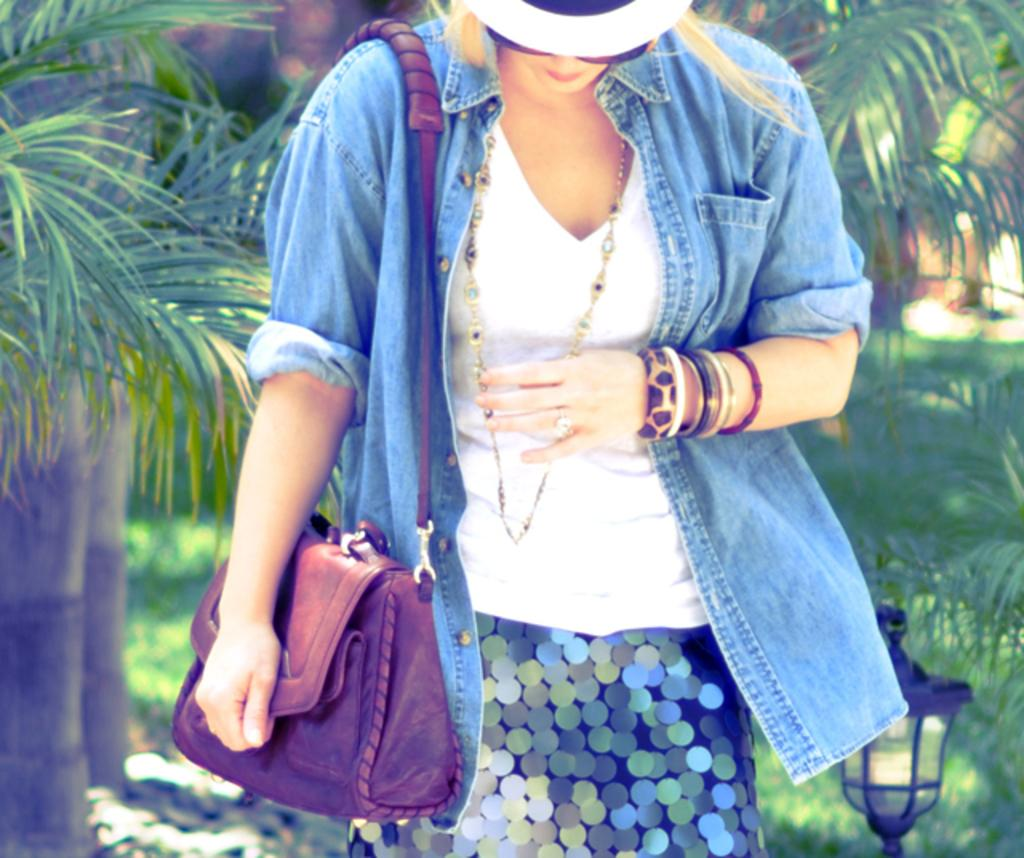What is the main subject of the image? The main subject of the image is a woman. What accessories is the woman wearing? The woman is wearing a cap, goggles, a blue color shirt, beautiful bangles, and a ring. What is the woman carrying in the image? The woman is carrying a bag. What can be seen in the background of the image? There are trees, grass, and a lamp in the background of the image. What type of caption is written on the woman's shirt in the image? There is no caption written on the woman's shirt in the image; it is a blue color shirt. How does the woman maintain her balance while walking on the snow in the image? There is no snow present in the image, and the woman is not walking; she is standing still. 